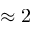<formula> <loc_0><loc_0><loc_500><loc_500>\approx 2</formula> 